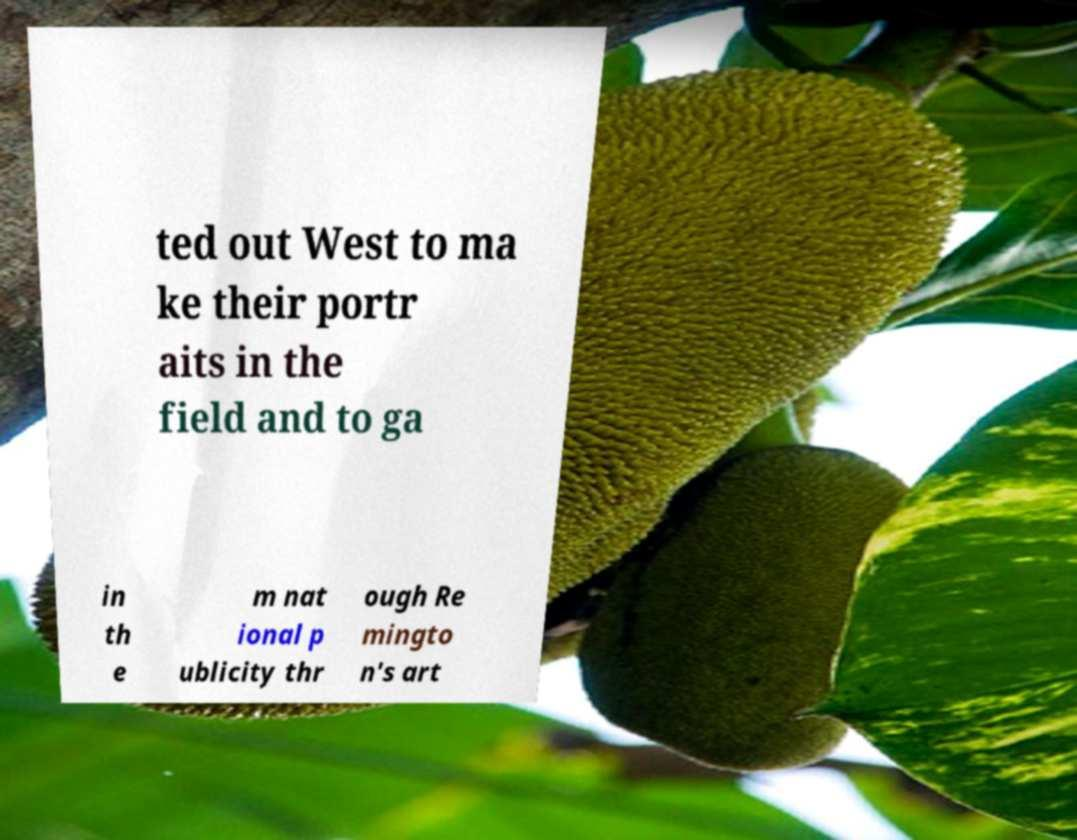Could you assist in decoding the text presented in this image and type it out clearly? ted out West to ma ke their portr aits in the field and to ga in th e m nat ional p ublicity thr ough Re mingto n's art 